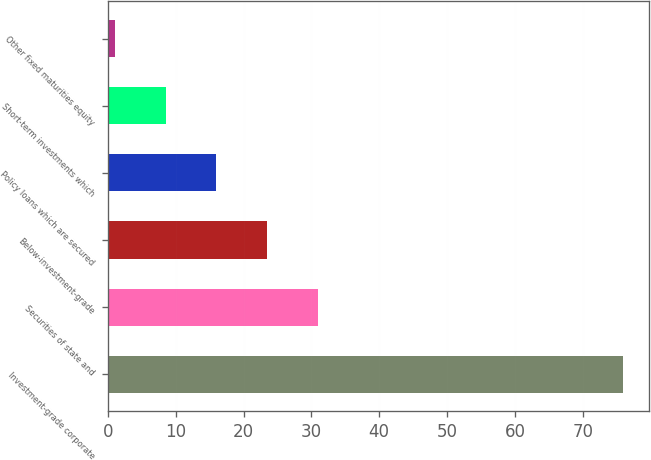<chart> <loc_0><loc_0><loc_500><loc_500><bar_chart><fcel>Investment-grade corporate<fcel>Securities of state and<fcel>Below-investment-grade<fcel>Policy loans which are secured<fcel>Short-term investments which<fcel>Other fixed maturities equity<nl><fcel>76<fcel>31<fcel>23.5<fcel>16<fcel>8.5<fcel>1<nl></chart> 